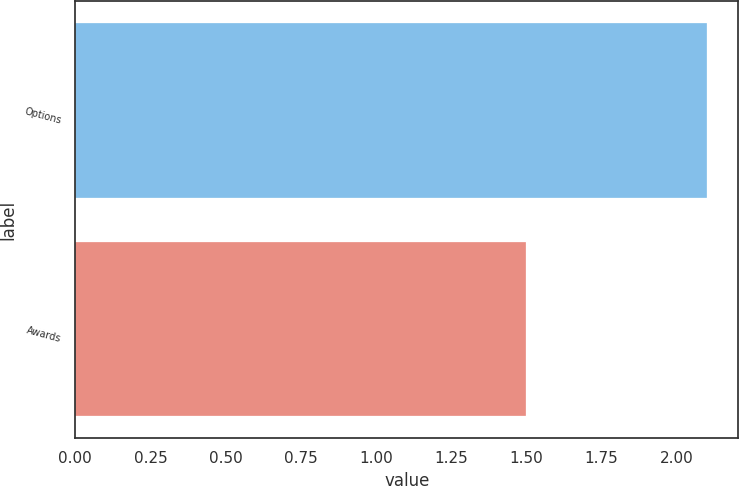Convert chart. <chart><loc_0><loc_0><loc_500><loc_500><bar_chart><fcel>Options<fcel>Awards<nl><fcel>2.1<fcel>1.5<nl></chart> 